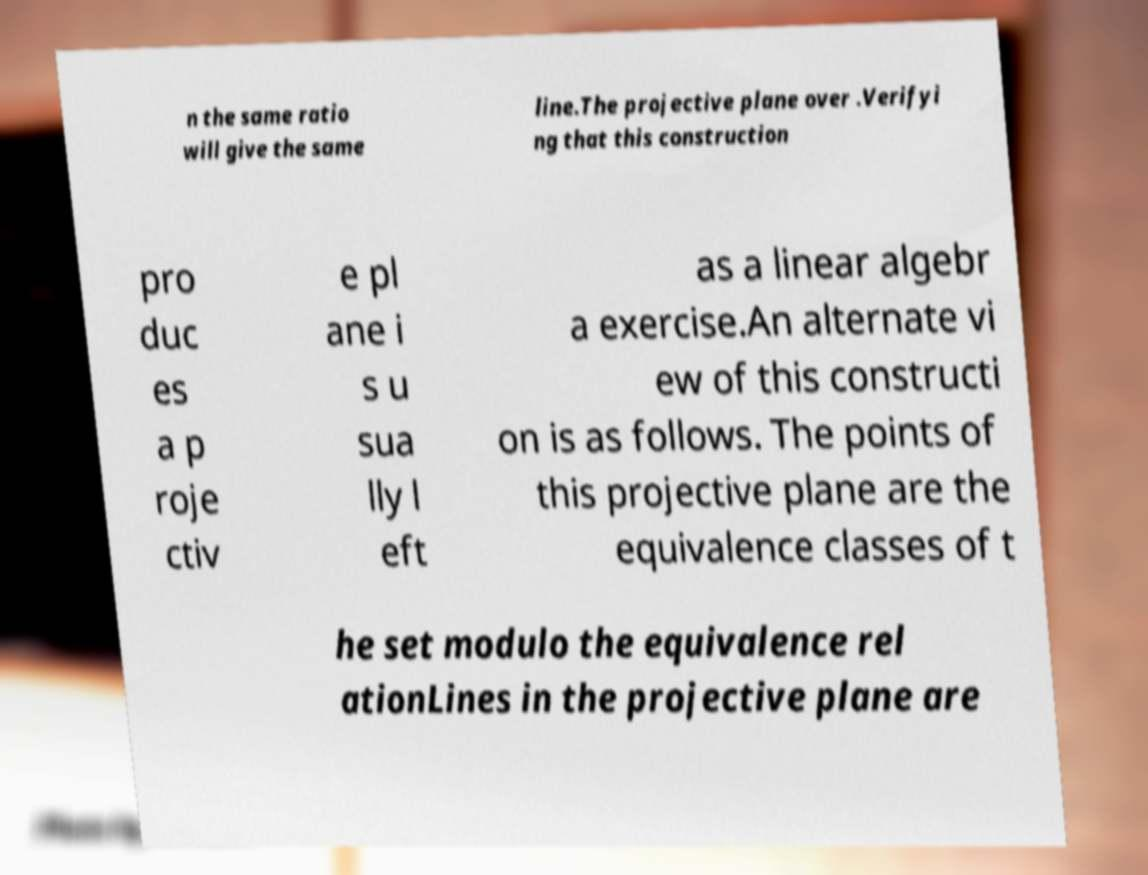For documentation purposes, I need the text within this image transcribed. Could you provide that? n the same ratio will give the same line.The projective plane over .Verifyi ng that this construction pro duc es a p roje ctiv e pl ane i s u sua lly l eft as a linear algebr a exercise.An alternate vi ew of this constructi on is as follows. The points of this projective plane are the equivalence classes of t he set modulo the equivalence rel ationLines in the projective plane are 